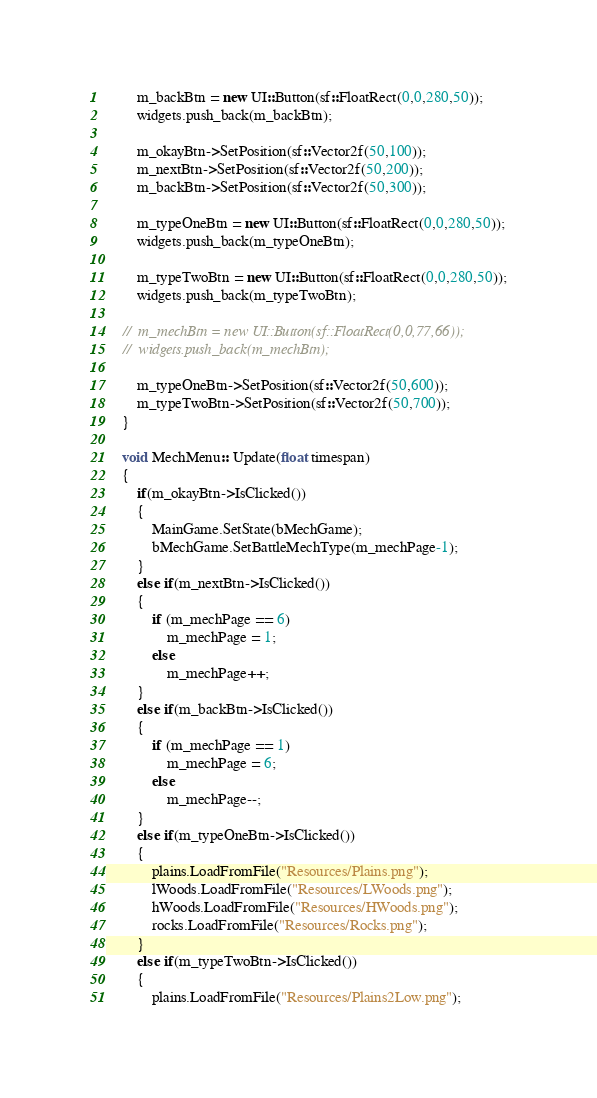Convert code to text. <code><loc_0><loc_0><loc_500><loc_500><_C++_>		m_backBtn = new UI::Button(sf::FloatRect(0,0,280,50));
		widgets.push_back(m_backBtn);

		m_okayBtn->SetPosition(sf::Vector2f(50,100));
		m_nextBtn->SetPosition(sf::Vector2f(50,200));
		m_backBtn->SetPosition(sf::Vector2f(50,300));

		m_typeOneBtn = new UI::Button(sf::FloatRect(0,0,280,50));
		widgets.push_back(m_typeOneBtn);

		m_typeTwoBtn = new UI::Button(sf::FloatRect(0,0,280,50));
		widgets.push_back(m_typeTwoBtn);

	//	m_mechBtn = new UI::Button(sf::FloatRect(0,0,77,66));
	//	widgets.push_back(m_mechBtn);

		m_typeOneBtn->SetPosition(sf::Vector2f(50,600));
		m_typeTwoBtn->SetPosition(sf::Vector2f(50,700));
	}

	void MechMenu:: Update(float timespan)
	{
		if(m_okayBtn->IsClicked())
		{
			MainGame.SetState(bMechGame);
			bMechGame.SetBattleMechType(m_mechPage-1);
		}
		else if(m_nextBtn->IsClicked())
		{
			if (m_mechPage == 6)
				m_mechPage = 1;
			else
				m_mechPage++;
		}
		else if(m_backBtn->IsClicked())
		{
			if (m_mechPage == 1)
				m_mechPage = 6;
			else
				m_mechPage--;
		}
		else if(m_typeOneBtn->IsClicked())
		{
			plains.LoadFromFile("Resources/Plains.png");
			lWoods.LoadFromFile("Resources/LWoods.png");
			hWoods.LoadFromFile("Resources/HWoods.png");
			rocks.LoadFromFile("Resources/Rocks.png");
		}
		else if(m_typeTwoBtn->IsClicked())
		{
			plains.LoadFromFile("Resources/Plains2Low.png");</code> 